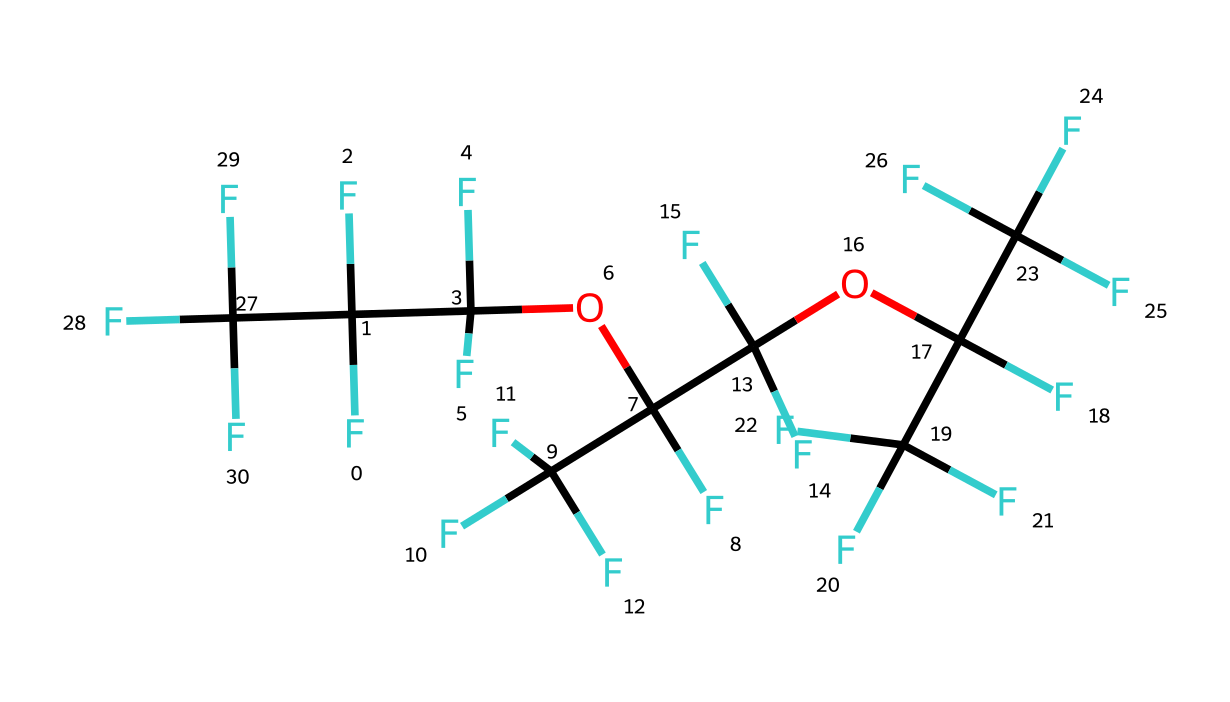how many carbon atoms are in the chemical structure? Count the instances of 'C' in the SMILES representation. There are 8 carbon atoms present in the structure.
Answer: 8 how many oxygen atoms are in the chemical structure? Similarly, count the instances of 'O' in the SMILES representation. There are 3 oxygen atoms found in the structure.
Answer: 3 what is the central functional group in this chemical? The presence of 'OC' indicates that the central functional group is an ether, which is characterized by the oxygen atom bonded to two carbon atoms.
Answer: ether what defines the stability of PFPE at extreme temperatures? The perfluoroalkyl groups (indicated by F) contribute to the thermal stability, making PFPE resistant to degradation at high temperatures.
Answer: thermal stability how does this chemical's structure contribute to its lubricating properties? The large number of fluorine atoms results in low surface energy, which reduces friction and wear, enhancing its lubricating capabilities.
Answer: low surface energy how is this chemical different from conventional lubricants? PFPE is non-toxic and shows better thermal stability and lubricating performance compared to traditional hydrocarbons, making it more suitable for extreme conditions.
Answer: non-toxic and thermal stability what is the significance of perfluorination in this chemical? Perfluorination enhances the chemical's resistance to chemical reactions and improves its performance in extreme environments, particularly in non-reactive conditions found on planets.
Answer: resistance to reactions 